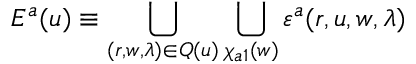<formula> <loc_0><loc_0><loc_500><loc_500>E ^ { a } ( u ) \equiv \bigcup _ { ( r , w , \lambda ) \in Q ( u ) } \bigcup _ { \chi _ { a 1 } ( w ) } \varepsilon ^ { a } ( r , u , w , \lambda )</formula> 